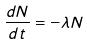<formula> <loc_0><loc_0><loc_500><loc_500>\frac { d N } { d t } = - \lambda N</formula> 